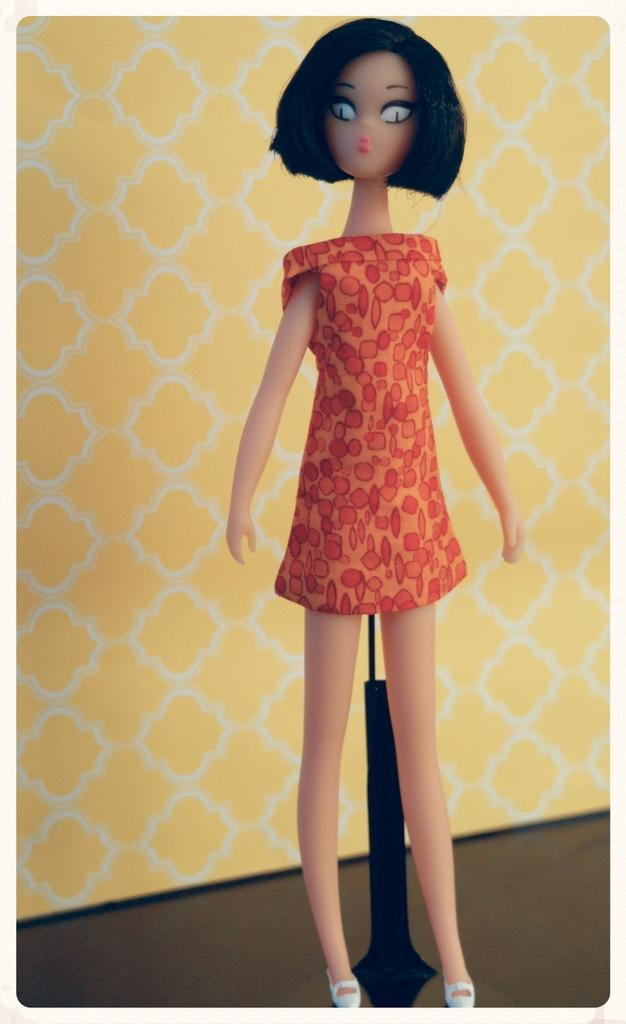What object can be seen in the image? There is a toy in the image. What color is the wall in the background of the image? There is a yellow wall in the background of the image. What type of alley can be seen in the image? There is no alley present in the image; it only features a toy and a yellow wall in the background. 